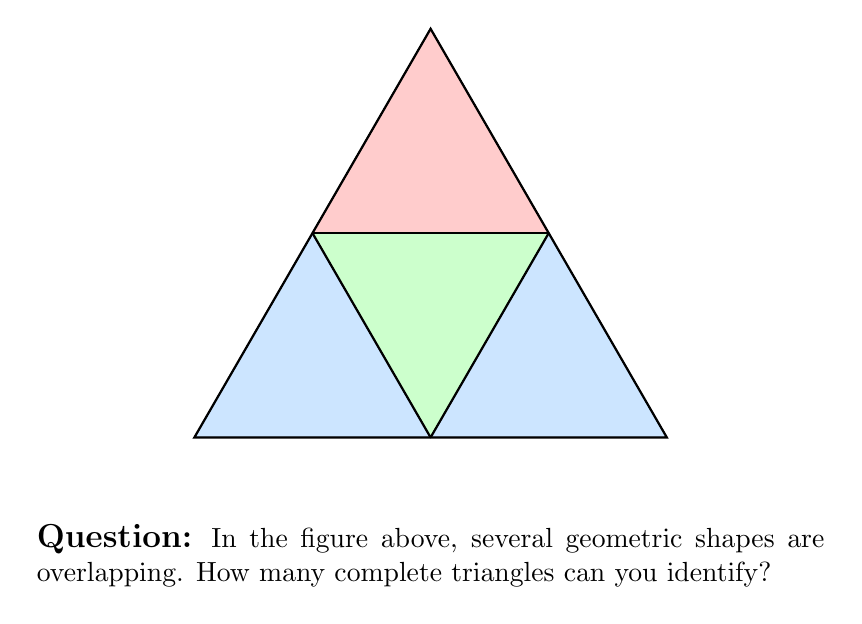Can you solve this math problem? Let's analyze this step-by-step:

1) First, we need to identify all the triangles in the figure. To do this systematically, let's look at different sizes of triangles:

   a) Large triangles: There is one large triangle that forms the outer boundary of the entire shape.

   b) Medium triangles: There are three medium-sized triangles:
      - The top triangle (colored in light red)
      - The bottom-left triangle (colored in light green)
      - The bottom-right triangle (formed by the overlap of the light blue and light green areas)

   c) Small triangles: There are three small triangles in the center, formed by the intersections of all three medium triangles.

2) Now, let's count:
   - 1 large triangle
   - 3 medium triangles
   - 3 small triangles

3) Therefore, the total number of complete triangles is:
   
   $$1 + 3 + 3 = 7$$

This problem tests the ability to identify geometric shapes in overlapping patterns, which is a common theme in Visual Intelligence Tests. It's particularly relevant for students in geometry classes, which are part of the mathematics curriculum in Israeli secondary schools like Stephen Lewis Secondary School.
Answer: 7 